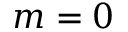Convert formula to latex. <formula><loc_0><loc_0><loc_500><loc_500>m = 0</formula> 